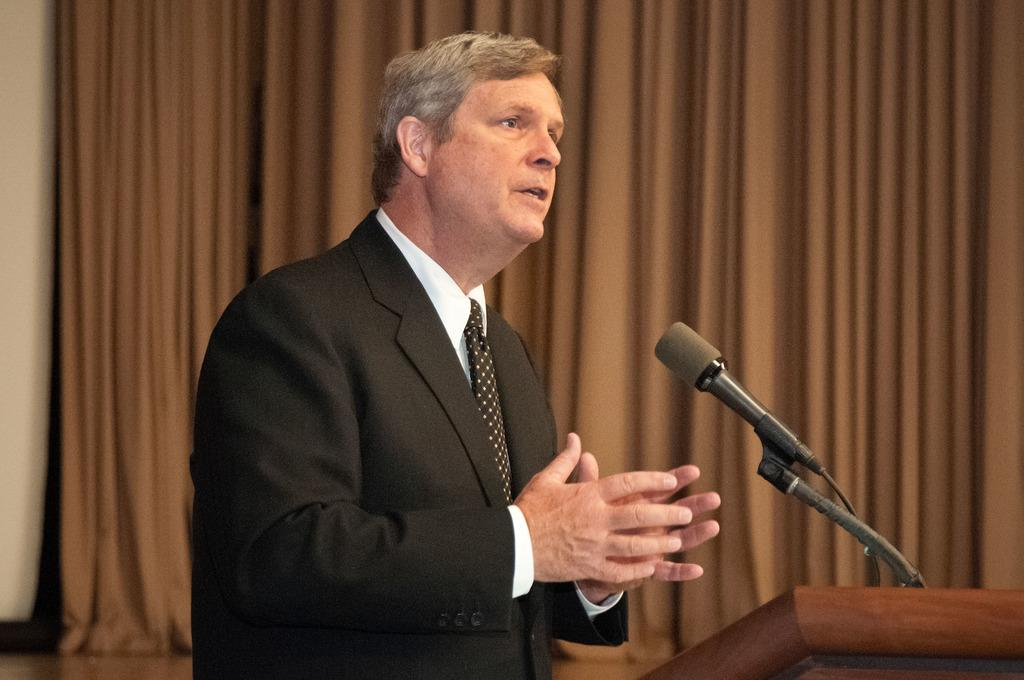What is the main subject of the image? The main subject of the image is a man. What is the man wearing in the image? The man is wearing a blazer and a tie in the image. What is the man doing in the image? The man is speaking on a microphone in the image. What can be seen in the background of the image? There are curtains in the background of the image. What type of road can be seen in the image? There is no road present in the image. How many songs is the man singing in the image? The image does not show the man singing any songs; he is speaking on a microphone. 